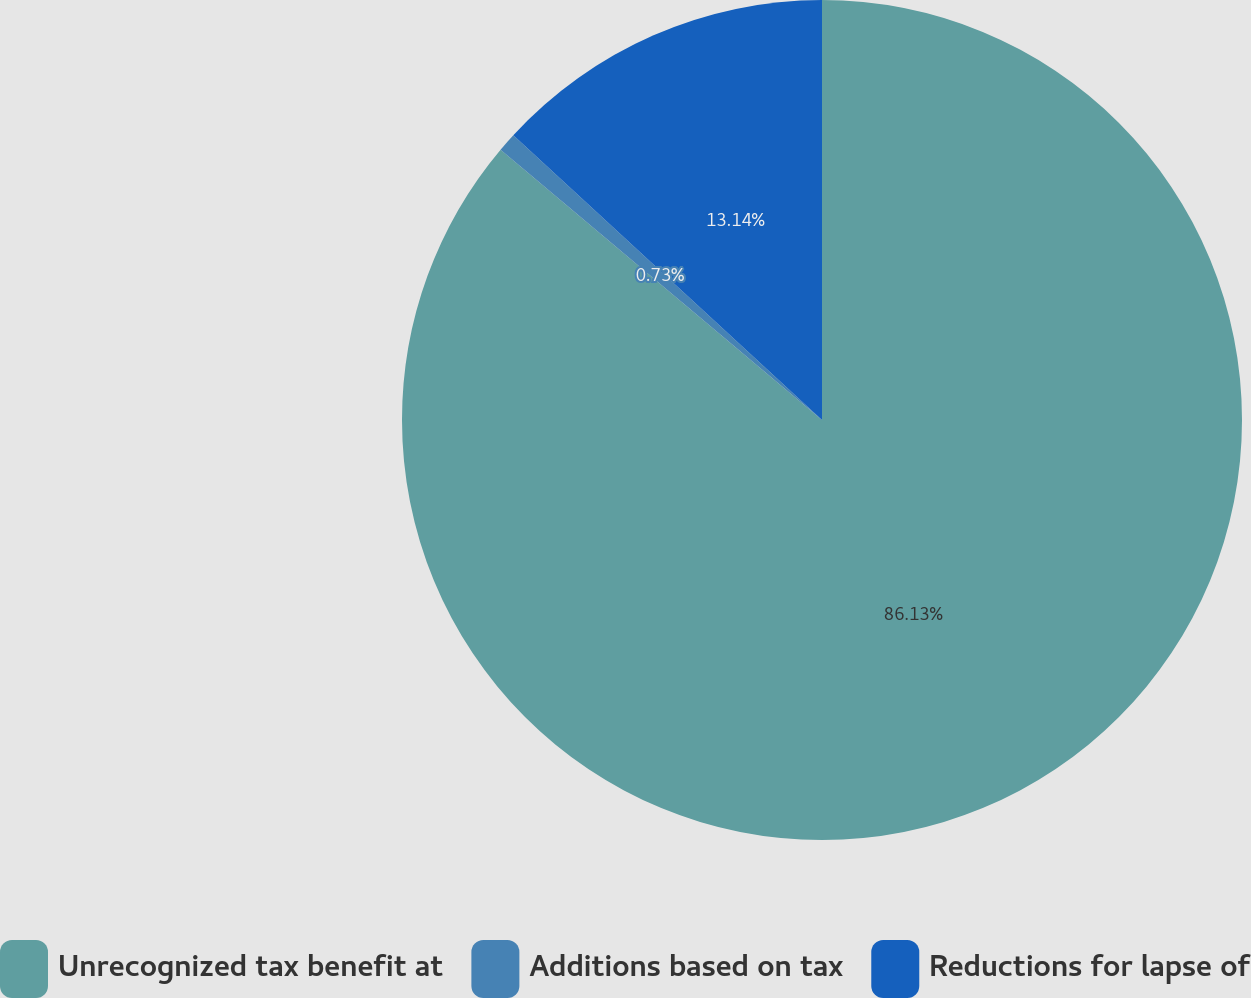Convert chart. <chart><loc_0><loc_0><loc_500><loc_500><pie_chart><fcel>Unrecognized tax benefit at<fcel>Additions based on tax<fcel>Reductions for lapse of<nl><fcel>86.13%<fcel>0.73%<fcel>13.14%<nl></chart> 